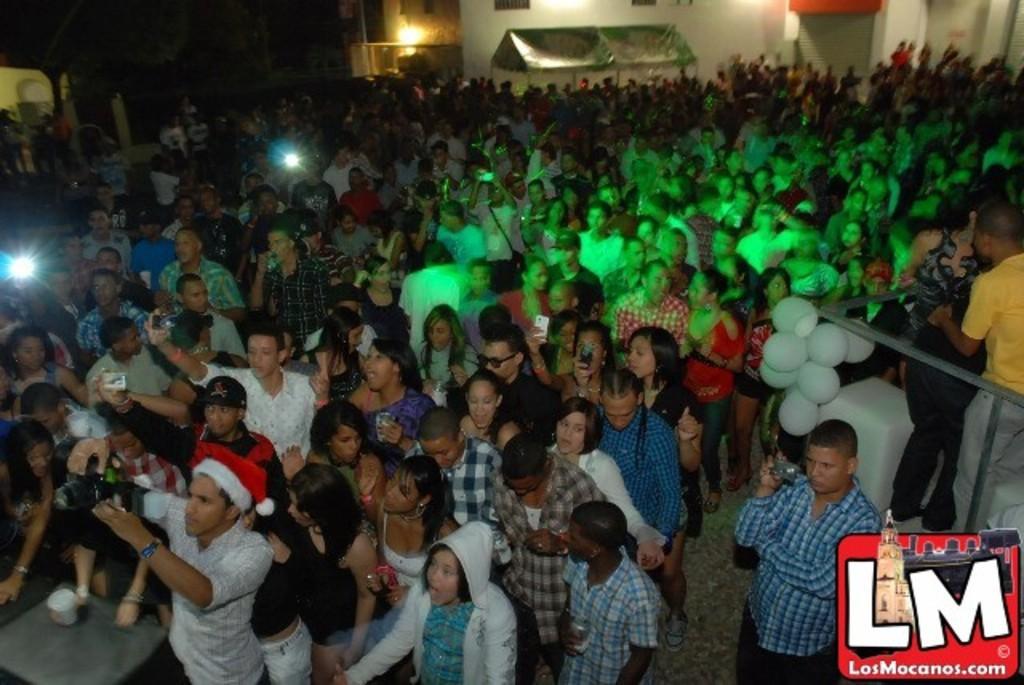Can you describe this image briefly? This picture is clicked outside. In the center we can see the group of people seems to be standing on the ground and holding some objects. On the right we can see the metal rods and the balloons. In the background we can see the buildings, shutter, lights and some other objects. At the bottom left corner there is a watermark on the image. 